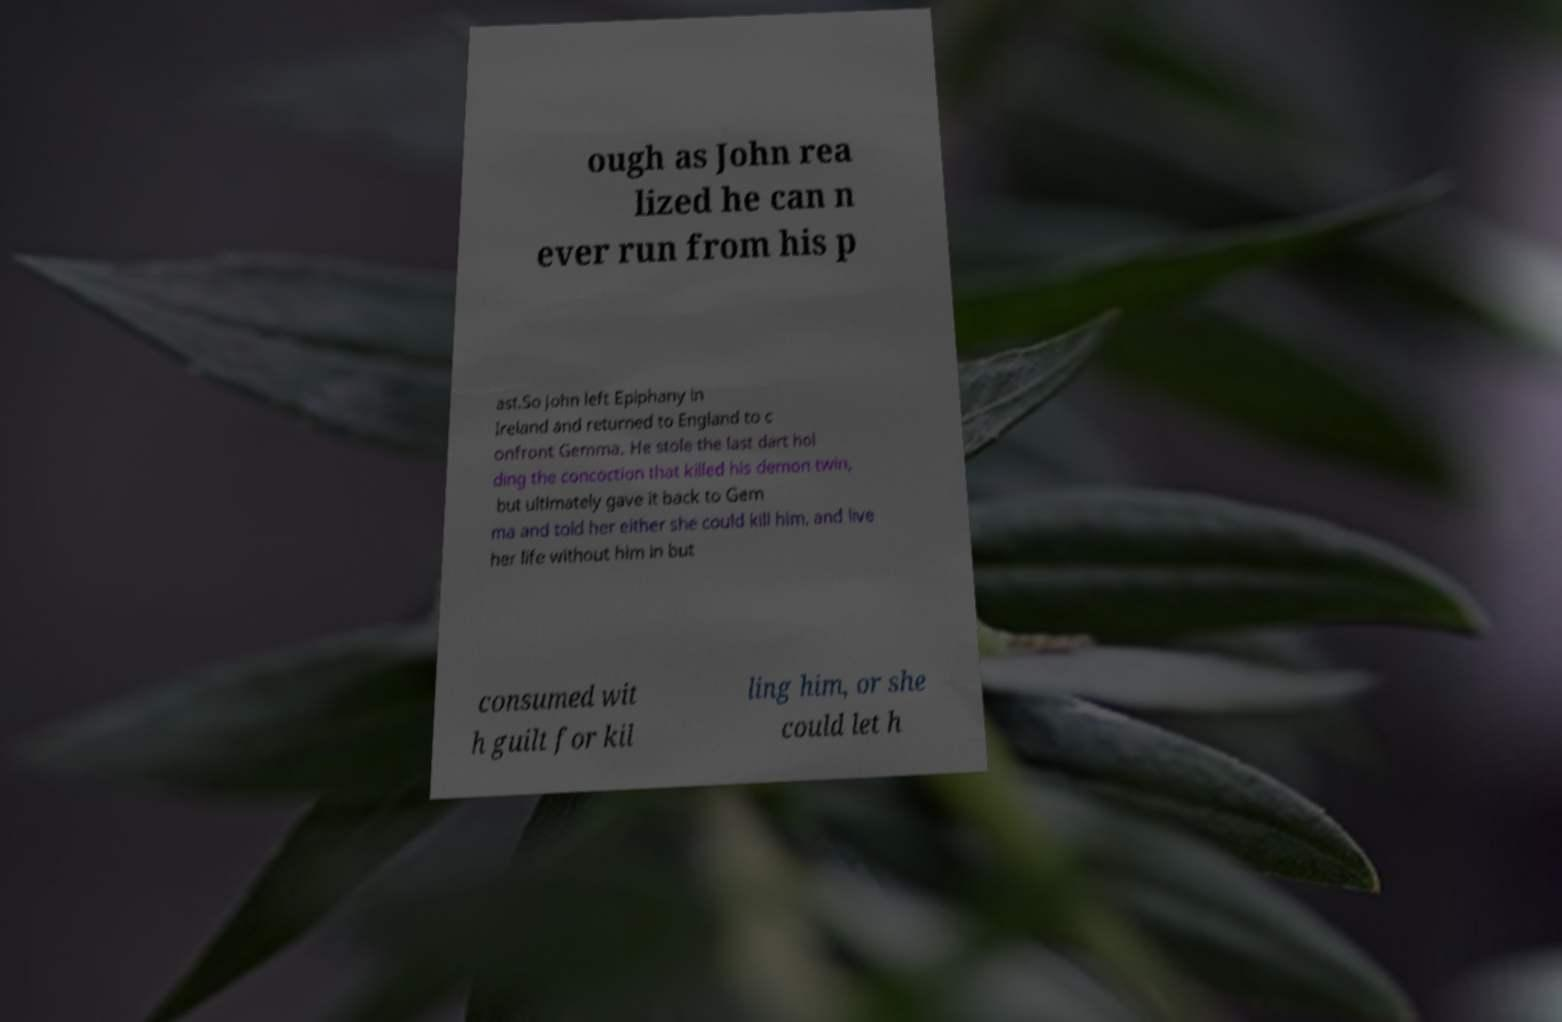I need the written content from this picture converted into text. Can you do that? ough as John rea lized he can n ever run from his p ast.So John left Epiphany in Ireland and returned to England to c onfront Gemma. He stole the last dart hol ding the concoction that killed his demon twin, but ultimately gave it back to Gem ma and told her either she could kill him, and live her life without him in but consumed wit h guilt for kil ling him, or she could let h 